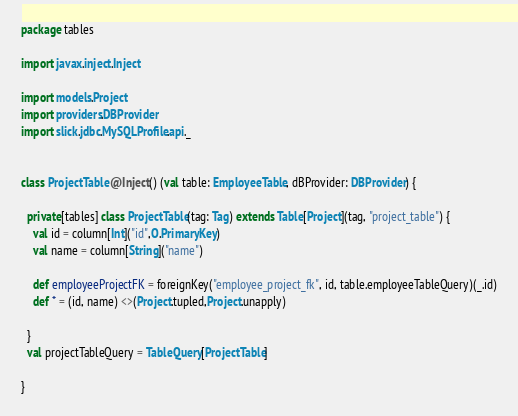<code> <loc_0><loc_0><loc_500><loc_500><_Scala_>package tables

import javax.inject.Inject

import models.Project
import providers.DBProvider
import slick.jdbc.MySQLProfile.api._


class ProjectTable @Inject() (val table: EmployeeTable, dBProvider: DBProvider) {

  private[tables] class ProjectTable(tag: Tag) extends Table[Project](tag, "project_table") {
    val id = column[Int]("id",O.PrimaryKey)
    val name = column[String]("name")

    def employeeProjectFK = foreignKey("employee_project_fk", id, table.employeeTableQuery)(_.id)
    def * = (id, name) <>(Project.tupled,Project.unapply)

  }
  val projectTableQuery = TableQuery[ProjectTable]

}
</code> 